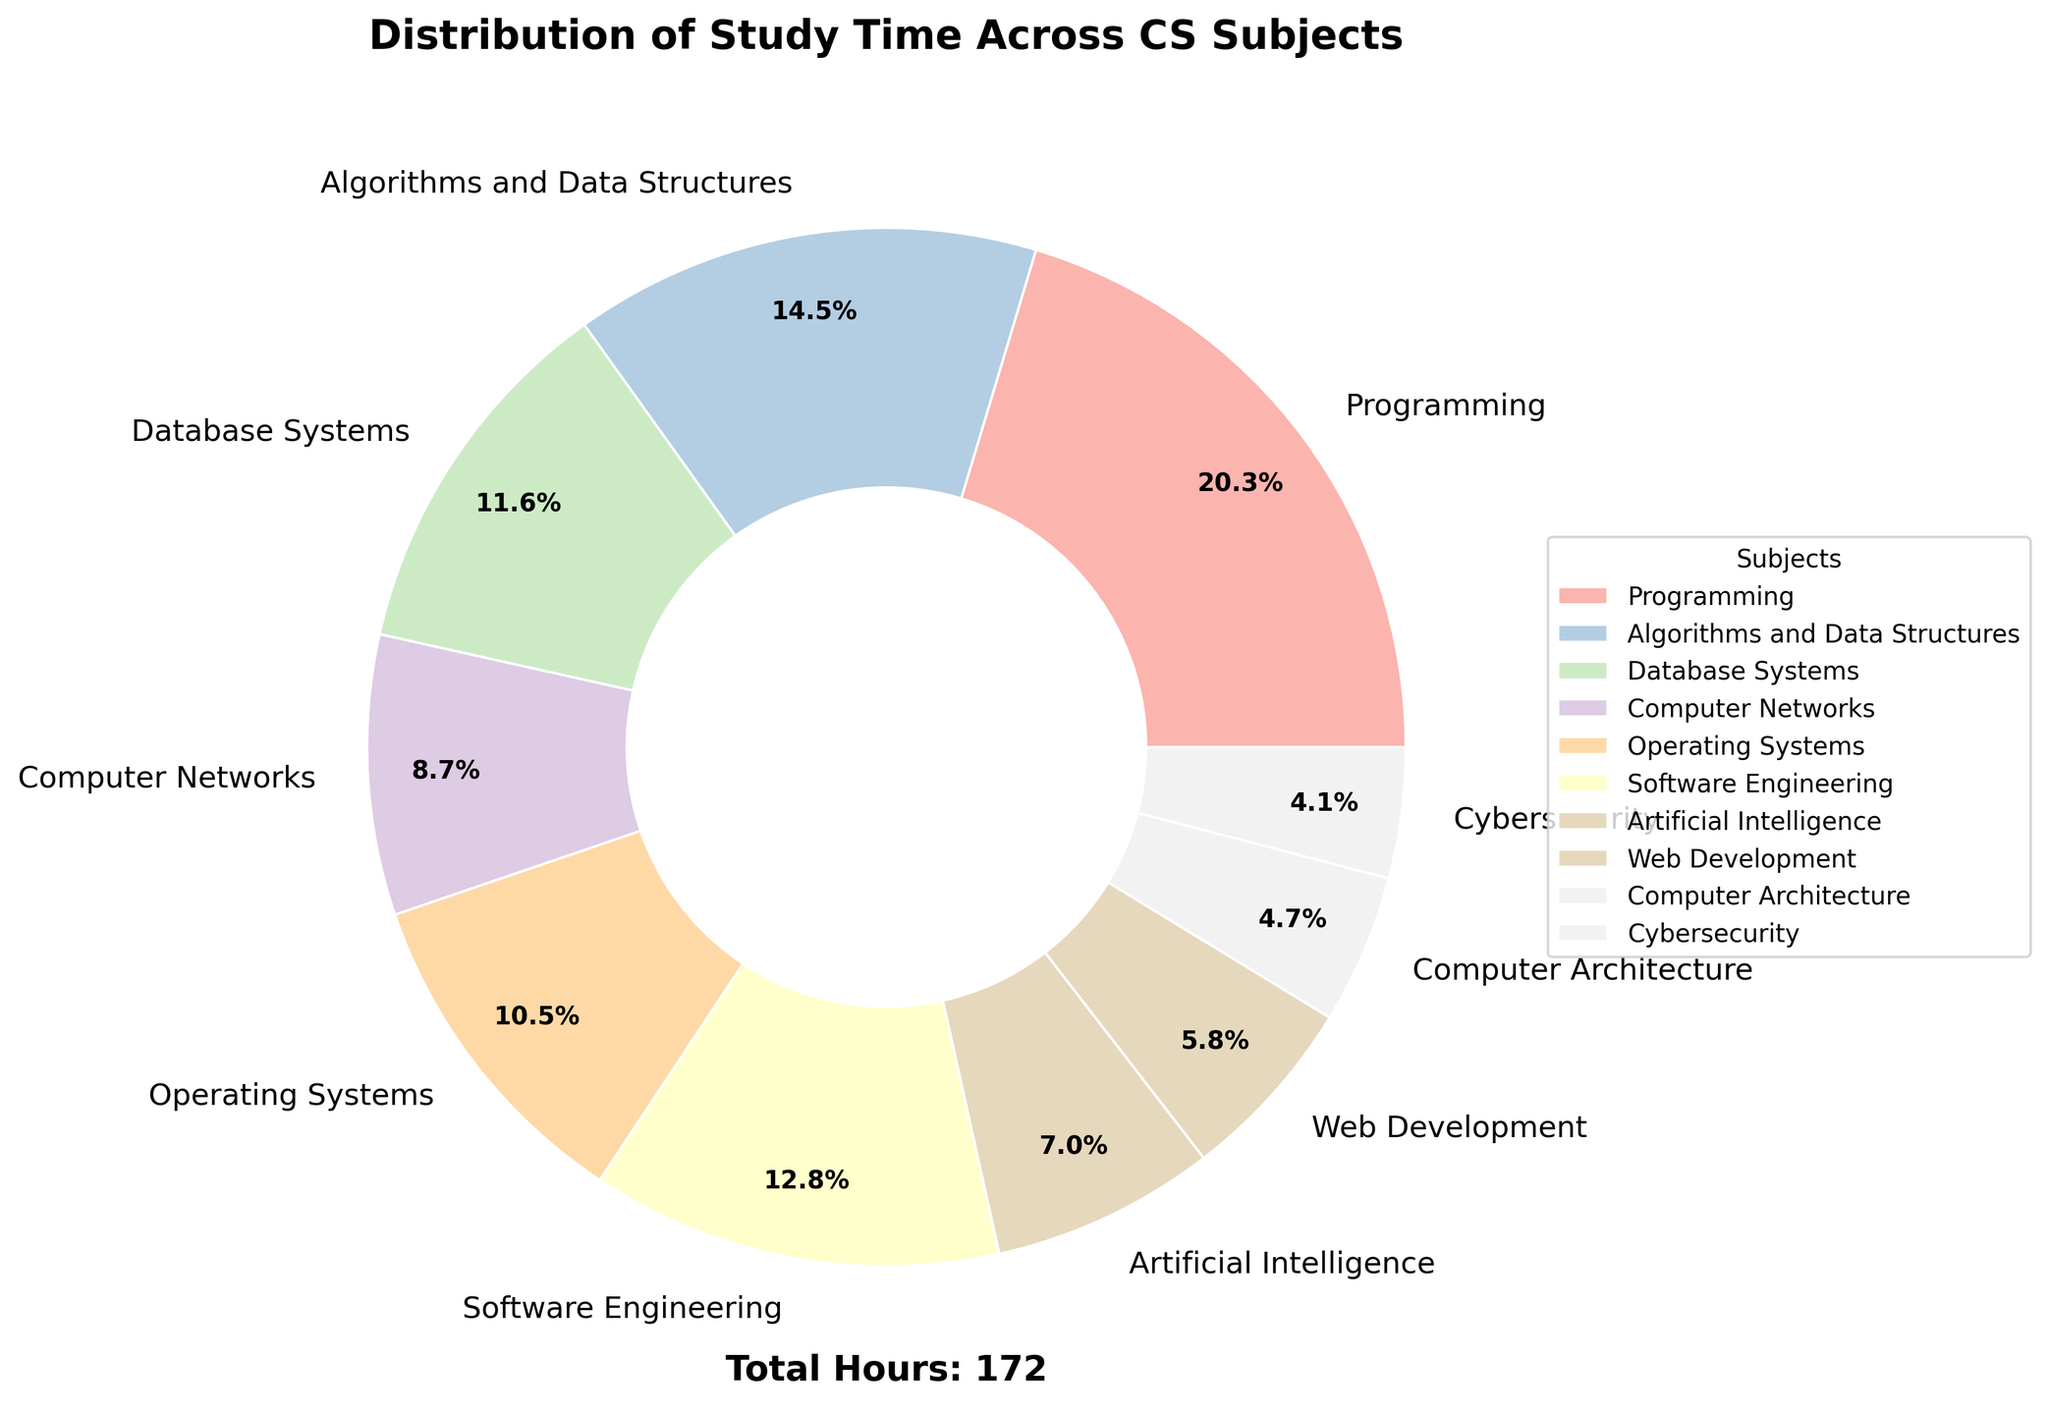What's the subject with the highest study time? The subject with the largest section of the pie chart, and labeled as 35.0%, indicates the highest study time.
Answer: Programming Which subject has the second highest study time? By looking at the pie chart, the section labeled as 25.0% represents the second highest study time.
Answer: Algorithms and Data Structures What percentage of study time is spent on Web Development compared to Computer Networks? The chart shows Web Development at 10% and Computer Networks at 15%. The ratio is 10/15, which simplifies to 2/3 or approximately 66.7%.
Answer: 66.7% How many subjects have a study time of less than 10%? By examining the pie chart, the sections labeled with percentages less than 10% are for Computer Architecture (8%) and Cybersecurity (7%).
Answer: 2 What is the combined study time percentage for Database Systems and Software Engineering? Adding the percentages for Database Systems (20%) and Software Engineering (22%) gives 20 + 22 = 42.
Answer: 42% Which subject has a smaller study time: Artificial Intelligence or Operating Systems? By comparing the sections, Artificial Intelligence is labeled 12%, which is smaller than Operating Systems labeled 18%.
Answer: Artificial Intelligence Is the percentage of time spent on Cybersecurity more or less than half of that spent on Operating Systems? The pie chart shows Cybersecurity at 7% and Operating Systems at 18%. Comparing these percentages, 7% is less than half of 18% (which is 9%).
Answer: Less What color is used to represent the Algorithms and Data Structures section? The pie chart uses a specific color from a pastel palette for each section. The section labeled 25% for Algorithms and Data Structures shows its unique color.
Answer: (describe the color seen in the chart, answer depends on actual colors used) If Programming and Algorithms and Data Structures are combined, what percentage of study time do they account for? Adding the percentages for Programming (35%) and Algorithms and Data Structures (25%) gives 35 + 25 = 60.
Answer: 60% Which sections represent less study time than Software Engineering? Sections with percentages smaller than Software Engineering (22%) include Database Systems (20%), Computer Networks (15%), Operating Systems (18%), Artificial Intelligence (12%), Web Development (10%), Computer Architecture (8%), and Cybersecurity (7%).
Answer: 7 sections: Database Systems, Computer Networks, Operating Systems, Artificial Intelligence, Web Development, Computer Architecture, Cybersecurity 